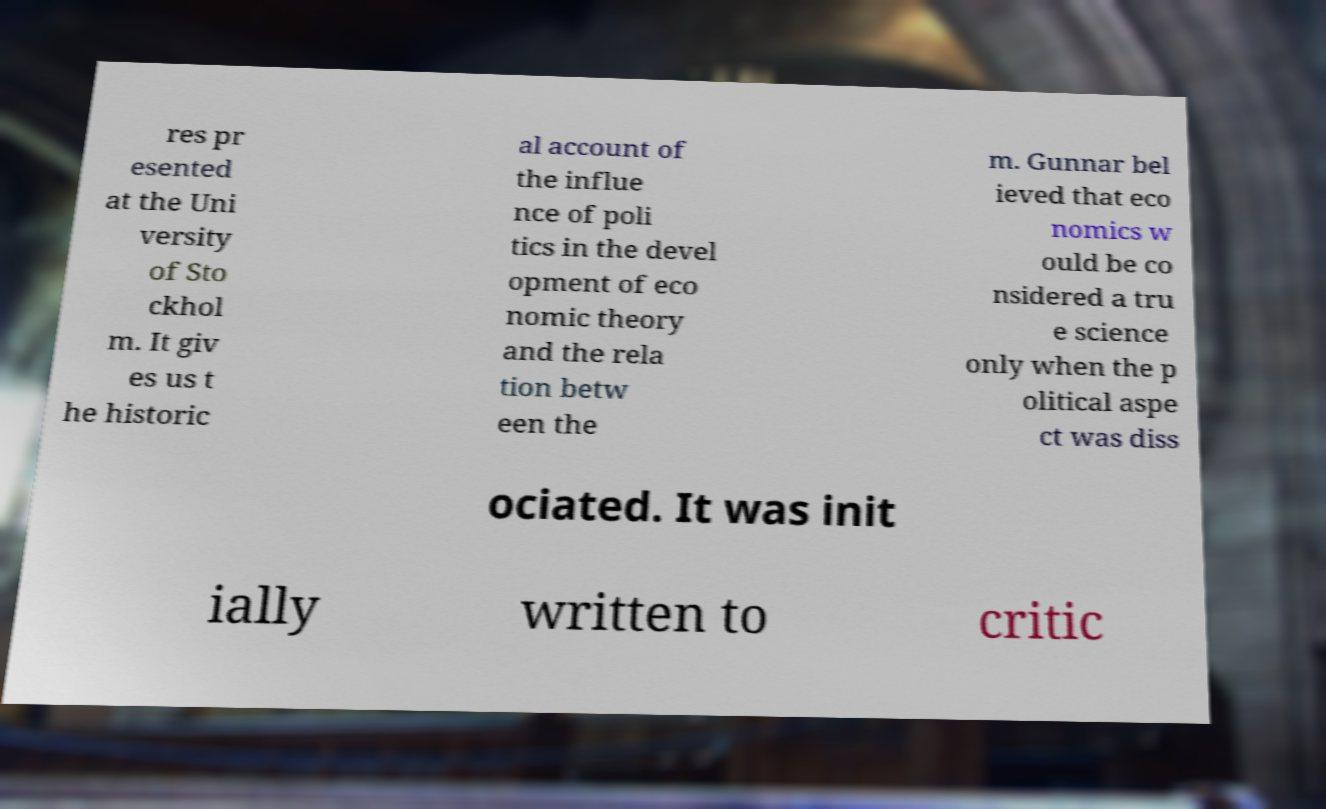What messages or text are displayed in this image? I need them in a readable, typed format. res pr esented at the Uni versity of Sto ckhol m. It giv es us t he historic al account of the influe nce of poli tics in the devel opment of eco nomic theory and the rela tion betw een the m. Gunnar bel ieved that eco nomics w ould be co nsidered a tru e science only when the p olitical aspe ct was diss ociated. It was init ially written to critic 